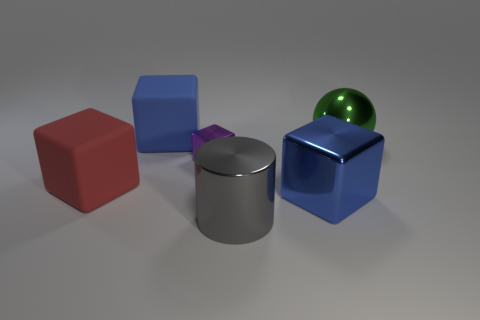Subtract all big blue matte blocks. How many blocks are left? 3 Subtract all cylinders. How many objects are left? 5 Add 1 brown metal objects. How many objects exist? 7 Subtract all purple blocks. How many blocks are left? 3 Subtract all large blue metal things. Subtract all blue metallic cubes. How many objects are left? 4 Add 1 big blue matte objects. How many big blue matte objects are left? 2 Add 4 matte things. How many matte things exist? 6 Subtract 0 cyan cubes. How many objects are left? 6 Subtract 2 cubes. How many cubes are left? 2 Subtract all brown cylinders. Subtract all purple cubes. How many cylinders are left? 1 